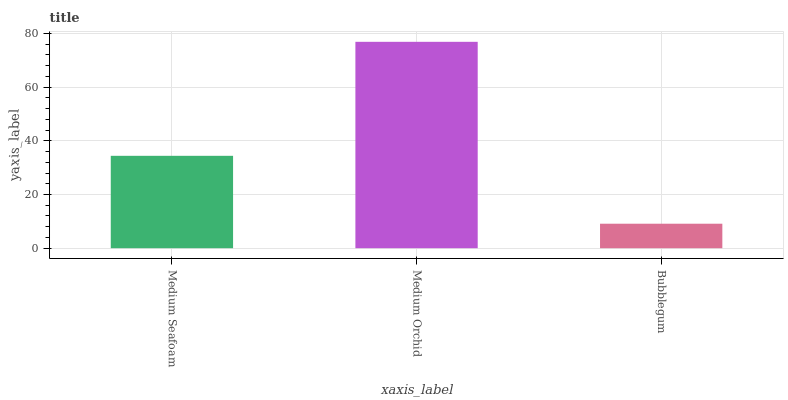Is Bubblegum the minimum?
Answer yes or no. Yes. Is Medium Orchid the maximum?
Answer yes or no. Yes. Is Medium Orchid the minimum?
Answer yes or no. No. Is Bubblegum the maximum?
Answer yes or no. No. Is Medium Orchid greater than Bubblegum?
Answer yes or no. Yes. Is Bubblegum less than Medium Orchid?
Answer yes or no. Yes. Is Bubblegum greater than Medium Orchid?
Answer yes or no. No. Is Medium Orchid less than Bubblegum?
Answer yes or no. No. Is Medium Seafoam the high median?
Answer yes or no. Yes. Is Medium Seafoam the low median?
Answer yes or no. Yes. Is Bubblegum the high median?
Answer yes or no. No. Is Bubblegum the low median?
Answer yes or no. No. 